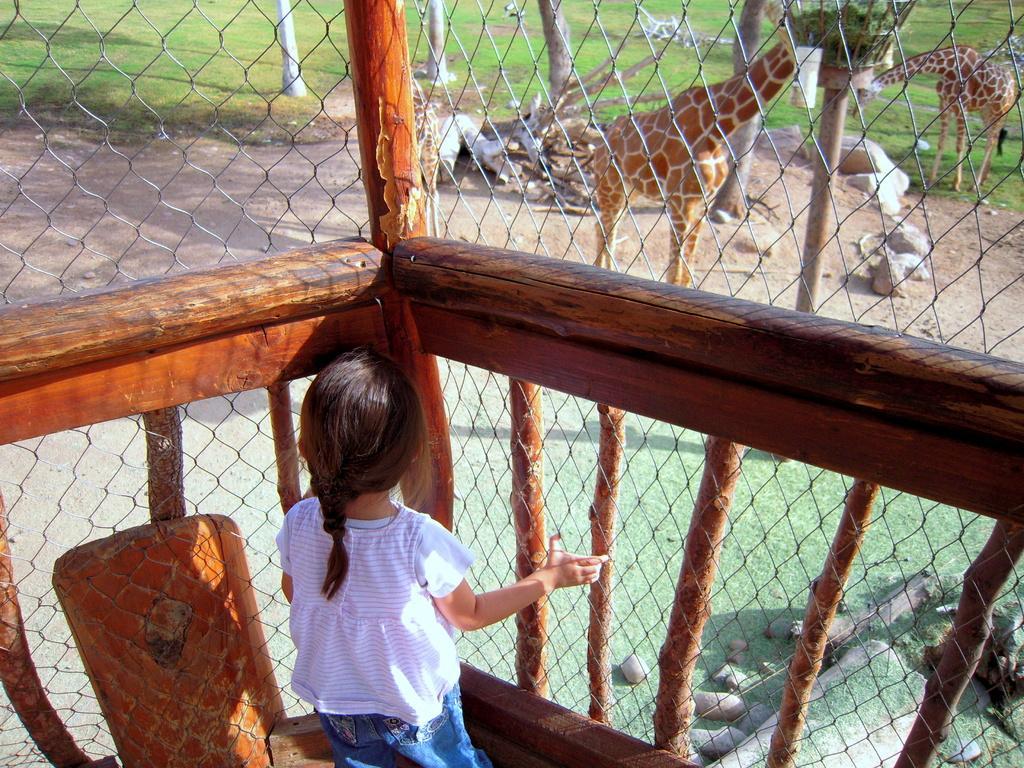Please provide a concise description of this image. In this image in the foreground there is one girl who is standing, and in the foreground there is a net and some wooden sticks. In the background there are two giraffes, trees, grass and one pole. 